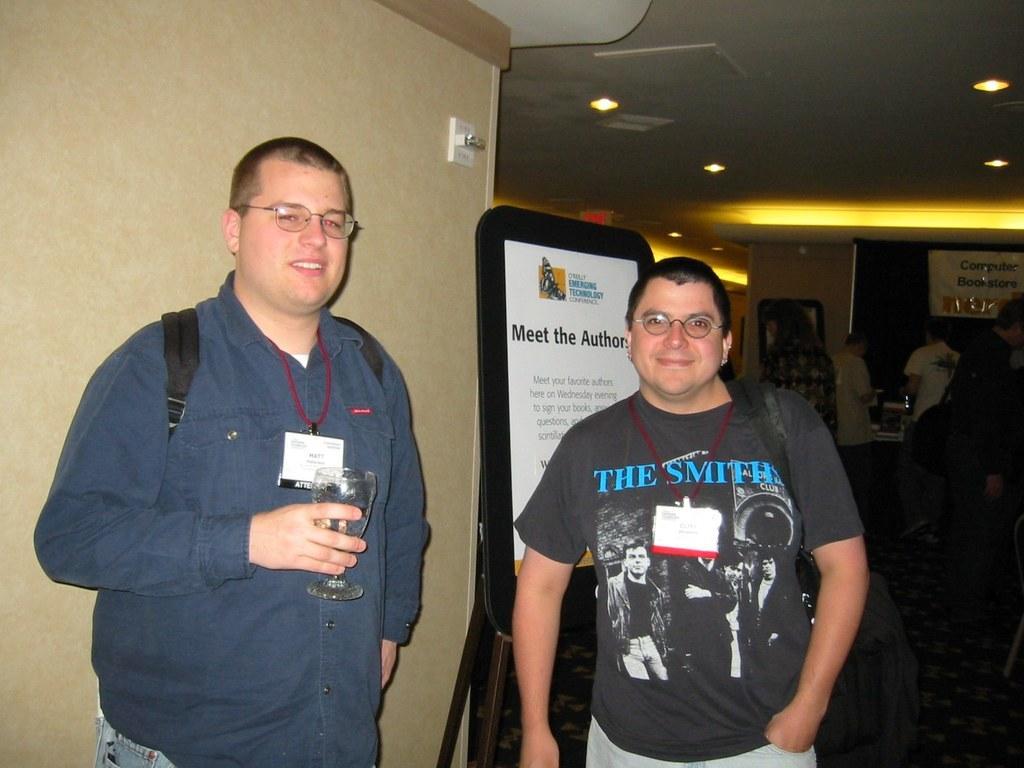Can you describe this image briefly? In this image I can see two persons wearing bags are standing and I can see a person is holding a glass in his hand. In the background I can see the wall, a board, the ceiling, few lights to the ceiling and few persons standing. 